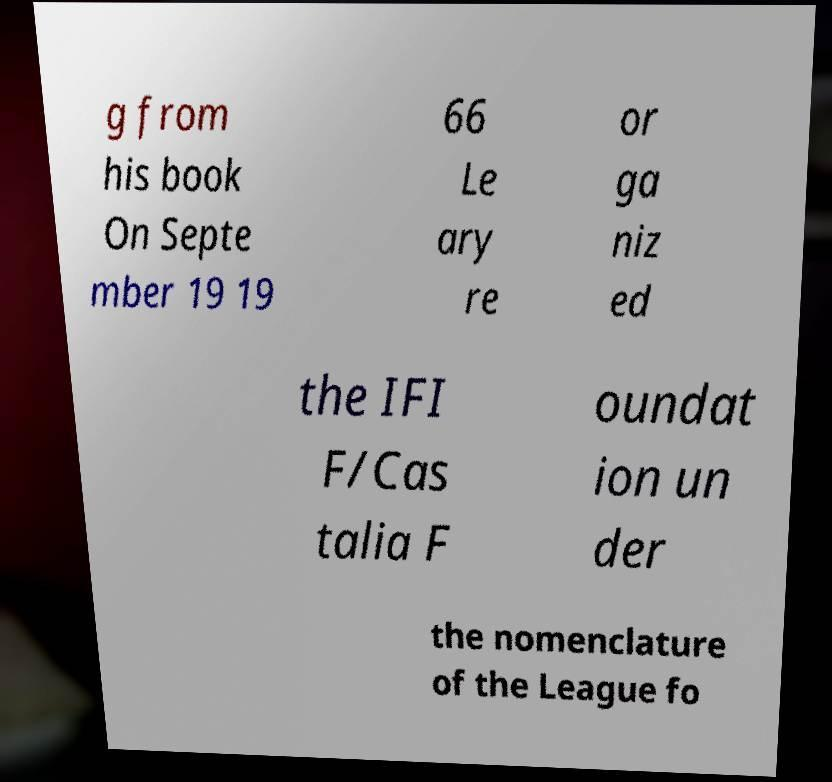For documentation purposes, I need the text within this image transcribed. Could you provide that? g from his book On Septe mber 19 19 66 Le ary re or ga niz ed the IFI F/Cas talia F oundat ion un der the nomenclature of the League fo 